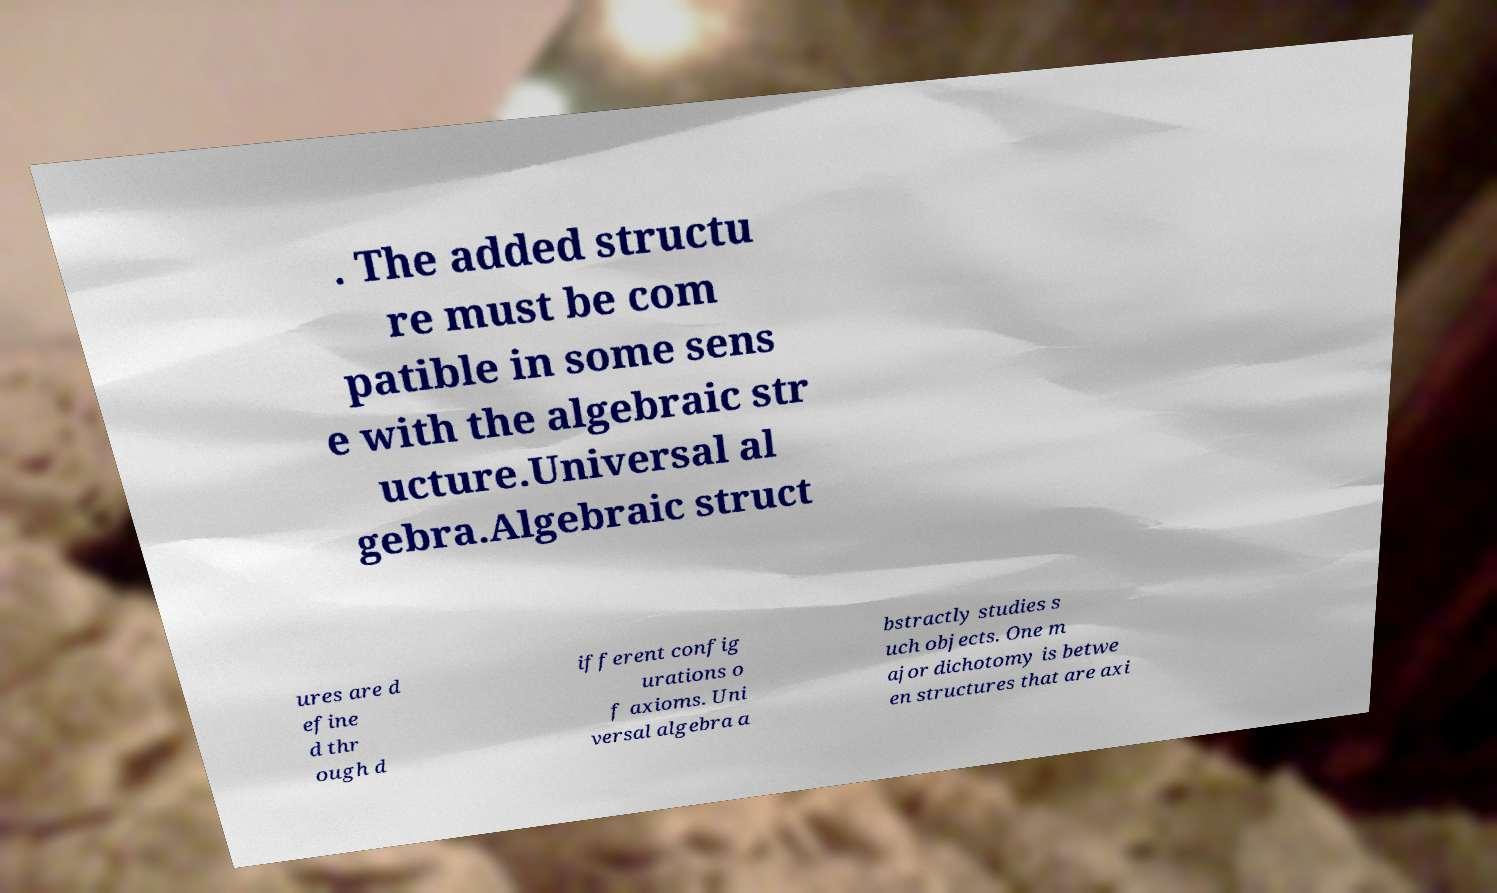Please identify and transcribe the text found in this image. . The added structu re must be com patible in some sens e with the algebraic str ucture.Universal al gebra.Algebraic struct ures are d efine d thr ough d ifferent config urations o f axioms. Uni versal algebra a bstractly studies s uch objects. One m ajor dichotomy is betwe en structures that are axi 